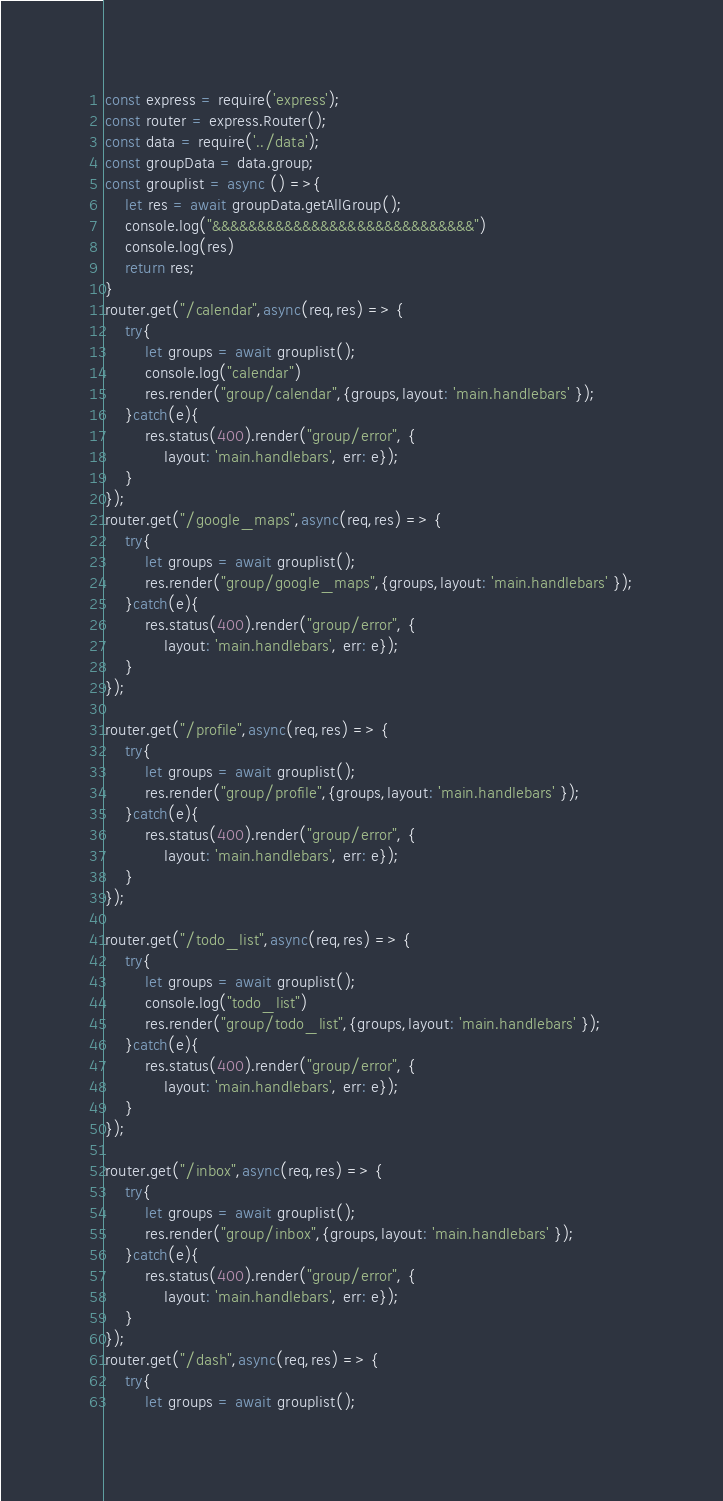<code> <loc_0><loc_0><loc_500><loc_500><_JavaScript_>const express = require('express');
const router = express.Router();
const data = require('../data');
const groupData = data.group;
const grouplist = async () =>{
    let res = await groupData.getAllGroup();
    console.log("&&&&&&&&&&&&&&&&&&&&&&&&&&&&&")
    console.log(res)
    return res;
}
router.get("/calendar",async(req,res) => {
    try{
        let groups = await grouplist();
        console.log("calendar")
        res.render("group/calendar",{groups,layout: 'main.handlebars' });
    }catch(e){
        res.status(400).render("group/error", { 
            layout: 'main.handlebars', err: e});
    }
});
router.get("/google_maps",async(req,res) => {
    try{
        let groups = await grouplist();
        res.render("group/google_maps",{groups,layout: 'main.handlebars' });
    }catch(e){
        res.status(400).render("group/error", { 
            layout: 'main.handlebars', err: e});
    }
});

router.get("/profile",async(req,res) => {
    try{
        let groups = await grouplist();
        res.render("group/profile",{groups,layout: 'main.handlebars' });
    }catch(e){
        res.status(400).render("group/error", { 
            layout: 'main.handlebars', err: e});
    }
});

router.get("/todo_list",async(req,res) => {
    try{
        let groups = await grouplist();
        console.log("todo_list")
        res.render("group/todo_list",{groups,layout: 'main.handlebars' });
    }catch(e){
        res.status(400).render("group/error", { 
            layout: 'main.handlebars', err: e});
    }
});

router.get("/inbox",async(req,res) => {
    try{
        let groups = await grouplist();
        res.render("group/inbox",{groups,layout: 'main.handlebars' });
    }catch(e){
        res.status(400).render("group/error", { 
            layout: 'main.handlebars', err: e});
    }
});
router.get("/dash",async(req,res) => {
    try{
        let groups = await grouplist();</code> 